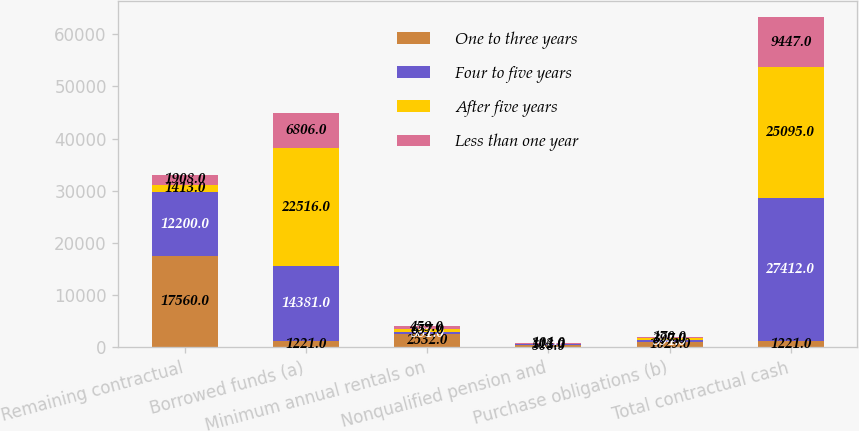Convert chart to OTSL. <chart><loc_0><loc_0><loc_500><loc_500><stacked_bar_chart><ecel><fcel>Remaining contractual<fcel>Borrowed funds (a)<fcel>Minimum annual rentals on<fcel>Nonqualified pension and<fcel>Purchase obligations (b)<fcel>Total contractual cash<nl><fcel>One to three years<fcel>17560<fcel>1221<fcel>2532<fcel>506<fcel>1029<fcel>1221<nl><fcel>Four to five years<fcel>12200<fcel>14381<fcel>381<fcel>56<fcel>394<fcel>27412<nl><fcel>After five years<fcel>1413<fcel>22516<fcel>657<fcel>112<fcel>397<fcel>25095<nl><fcel>Less than one year<fcel>1908<fcel>6806<fcel>459<fcel>104<fcel>170<fcel>9447<nl></chart> 